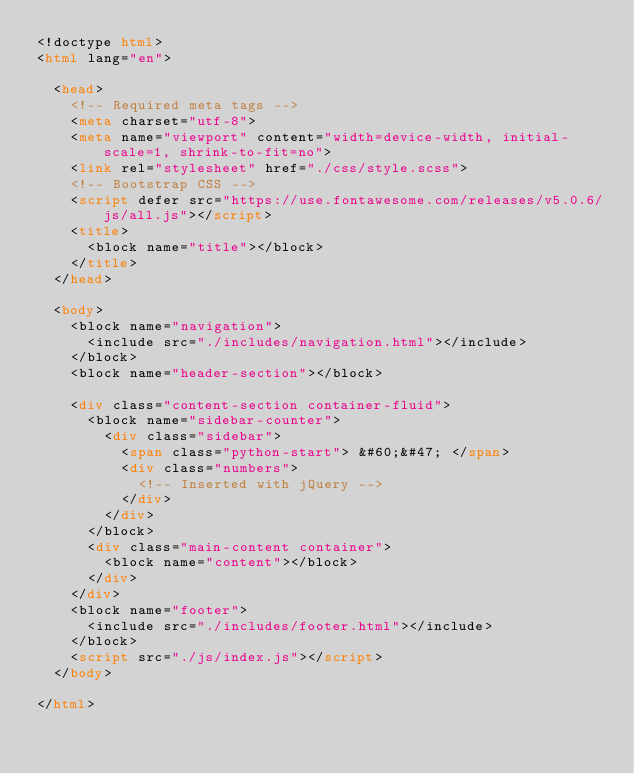<code> <loc_0><loc_0><loc_500><loc_500><_HTML_><!doctype html>
<html lang="en">

  <head>
    <!-- Required meta tags -->
    <meta charset="utf-8">
    <meta name="viewport" content="width=device-width, initial-scale=1, shrink-to-fit=no">
    <link rel="stylesheet" href="./css/style.scss">
    <!-- Bootstrap CSS -->
    <script defer src="https://use.fontawesome.com/releases/v5.0.6/js/all.js"></script>
    <title>
      <block name="title"></block>
    </title>
  </head>

  <body>
    <block name="navigation">
      <include src="./includes/navigation.html"></include>
    </block>
    <block name="header-section"></block>

    <div class="content-section container-fluid">
      <block name="sidebar-counter">
        <div class="sidebar">
          <span class="python-start"> &#60;&#47; </span>
          <div class="numbers">
            <!-- Inserted with jQuery -->
          </div>
        </div>
      </block>
      <div class="main-content container">
        <block name="content"></block>
      </div>
    </div>
    <block name="footer">
      <include src="./includes/footer.html"></include>
    </block>
    <script src="./js/index.js"></script>
  </body>

</html>
</code> 